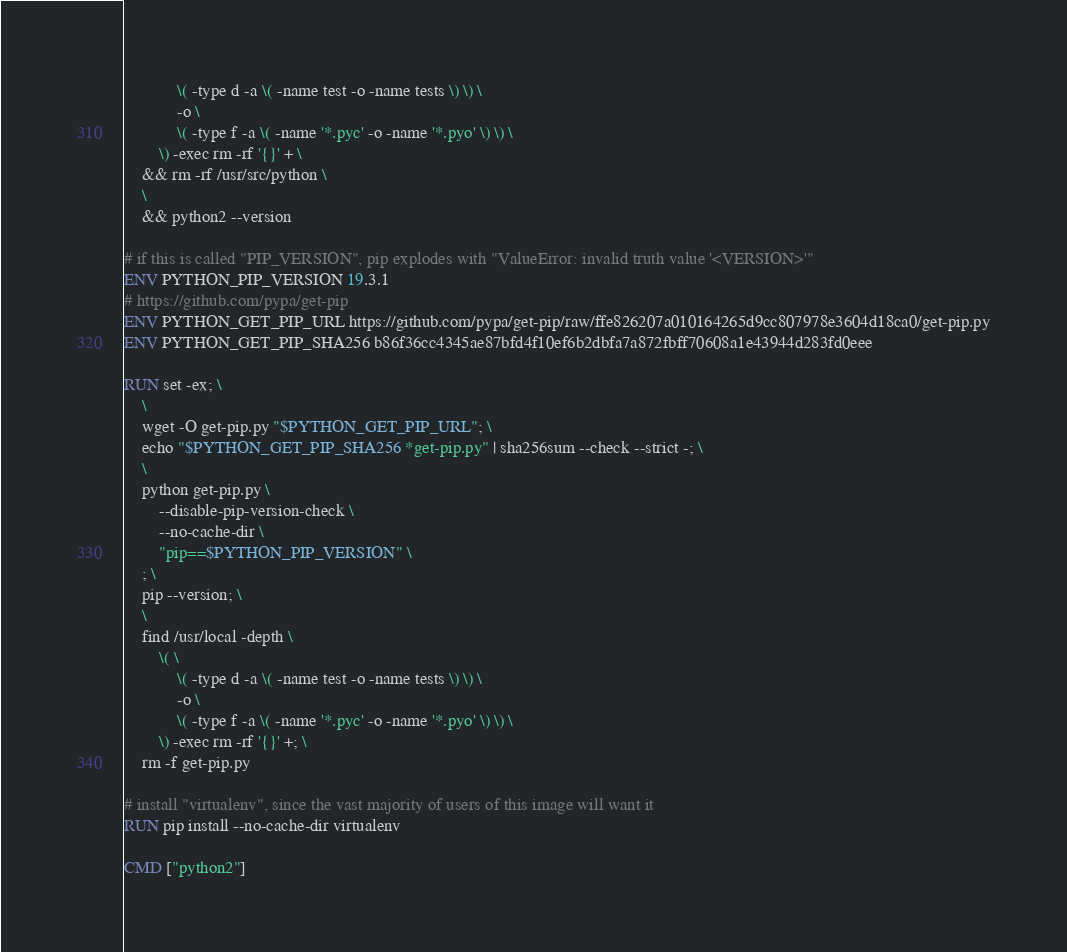<code> <loc_0><loc_0><loc_500><loc_500><_Dockerfile_>			\( -type d -a \( -name test -o -name tests \) \) \
			-o \
			\( -type f -a \( -name '*.pyc' -o -name '*.pyo' \) \) \
		\) -exec rm -rf '{}' + \
	&& rm -rf /usr/src/python \
	\
	&& python2 --version

# if this is called "PIP_VERSION", pip explodes with "ValueError: invalid truth value '<VERSION>'"
ENV PYTHON_PIP_VERSION 19.3.1
# https://github.com/pypa/get-pip
ENV PYTHON_GET_PIP_URL https://github.com/pypa/get-pip/raw/ffe826207a010164265d9cc807978e3604d18ca0/get-pip.py
ENV PYTHON_GET_PIP_SHA256 b86f36cc4345ae87bfd4f10ef6b2dbfa7a872fbff70608a1e43944d283fd0eee

RUN set -ex; \
	\
	wget -O get-pip.py "$PYTHON_GET_PIP_URL"; \
	echo "$PYTHON_GET_PIP_SHA256 *get-pip.py" | sha256sum --check --strict -; \
	\
	python get-pip.py \
		--disable-pip-version-check \
		--no-cache-dir \
		"pip==$PYTHON_PIP_VERSION" \
	; \
	pip --version; \
	\
	find /usr/local -depth \
		\( \
			\( -type d -a \( -name test -o -name tests \) \) \
			-o \
			\( -type f -a \( -name '*.pyc' -o -name '*.pyo' \) \) \
		\) -exec rm -rf '{}' +; \
	rm -f get-pip.py

# install "virtualenv", since the vast majority of users of this image will want it
RUN pip install --no-cache-dir virtualenv

CMD ["python2"]
</code> 